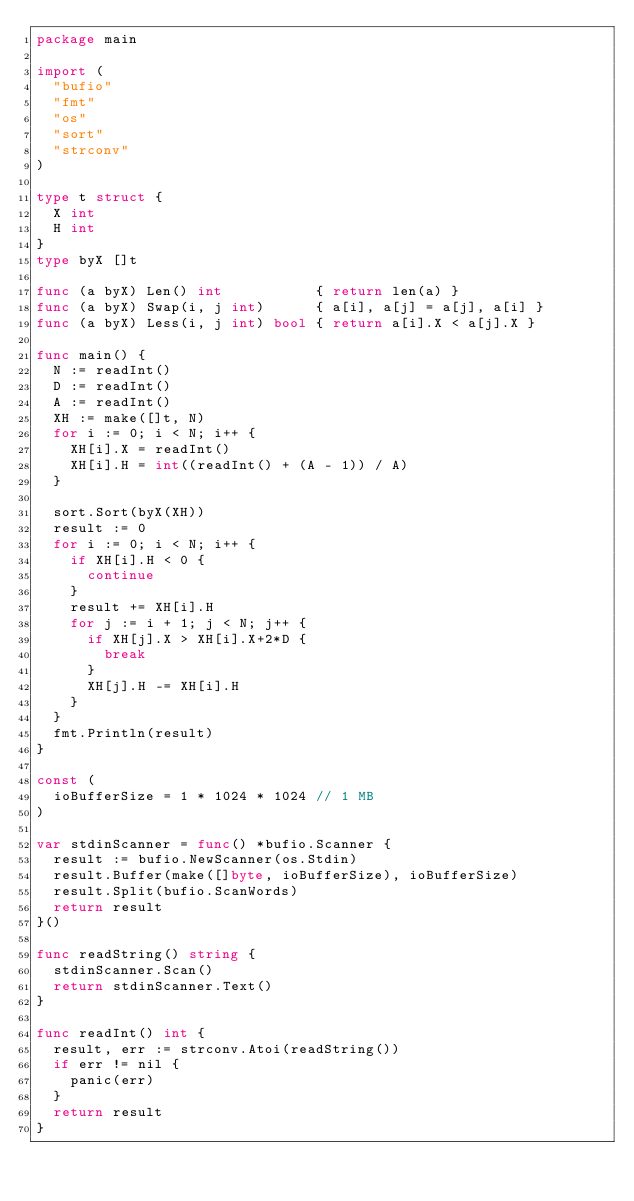<code> <loc_0><loc_0><loc_500><loc_500><_Go_>package main

import (
	"bufio"
	"fmt"
	"os"
	"sort"
	"strconv"
)

type t struct {
	X int
	H int
}
type byX []t

func (a byX) Len() int           { return len(a) }
func (a byX) Swap(i, j int)      { a[i], a[j] = a[j], a[i] }
func (a byX) Less(i, j int) bool { return a[i].X < a[j].X }

func main() {
	N := readInt()
	D := readInt()
	A := readInt()
	XH := make([]t, N)
	for i := 0; i < N; i++ {
		XH[i].X = readInt()
		XH[i].H = int((readInt() + (A - 1)) / A)
	}

	sort.Sort(byX(XH))
	result := 0
	for i := 0; i < N; i++ {
		if XH[i].H < 0 {
			continue
		}
		result += XH[i].H
		for j := i + 1; j < N; j++ {
			if XH[j].X > XH[i].X+2*D {
				break
			}
			XH[j].H -= XH[i].H
		}
	}
	fmt.Println(result)
}

const (
	ioBufferSize = 1 * 1024 * 1024 // 1 MB
)

var stdinScanner = func() *bufio.Scanner {
	result := bufio.NewScanner(os.Stdin)
	result.Buffer(make([]byte, ioBufferSize), ioBufferSize)
	result.Split(bufio.ScanWords)
	return result
}()

func readString() string {
	stdinScanner.Scan()
	return stdinScanner.Text()
}

func readInt() int {
	result, err := strconv.Atoi(readString())
	if err != nil {
		panic(err)
	}
	return result
}
</code> 